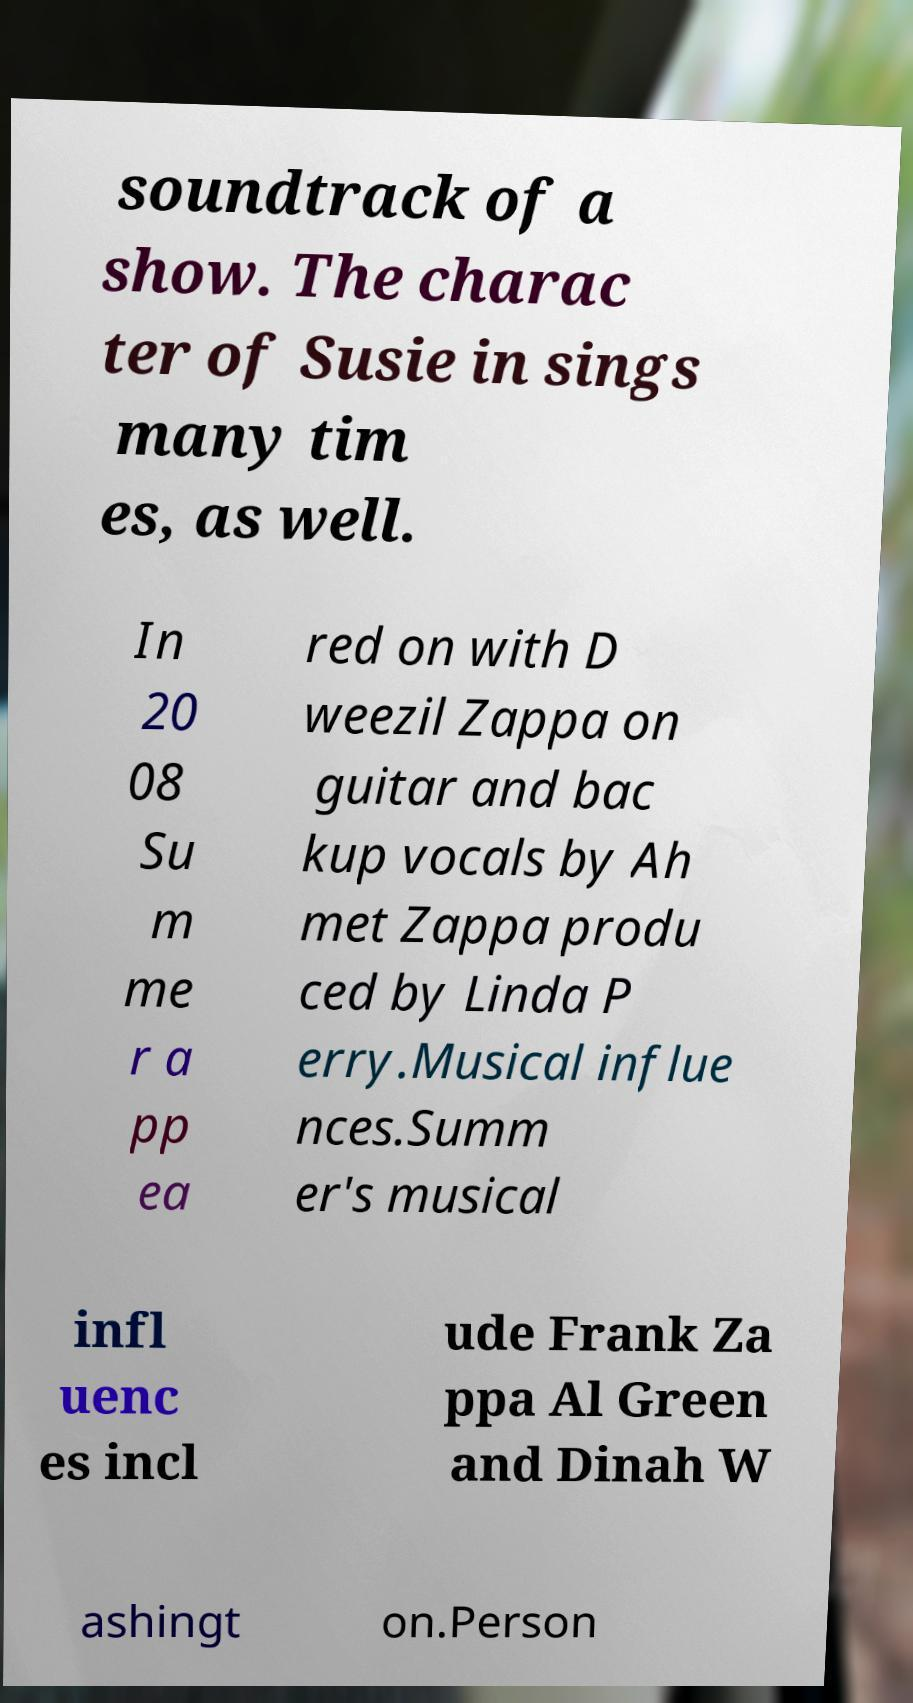For documentation purposes, I need the text within this image transcribed. Could you provide that? soundtrack of a show. The charac ter of Susie in sings many tim es, as well. In 20 08 Su m me r a pp ea red on with D weezil Zappa on guitar and bac kup vocals by Ah met Zappa produ ced by Linda P erry.Musical influe nces.Summ er's musical infl uenc es incl ude Frank Za ppa Al Green and Dinah W ashingt on.Person 